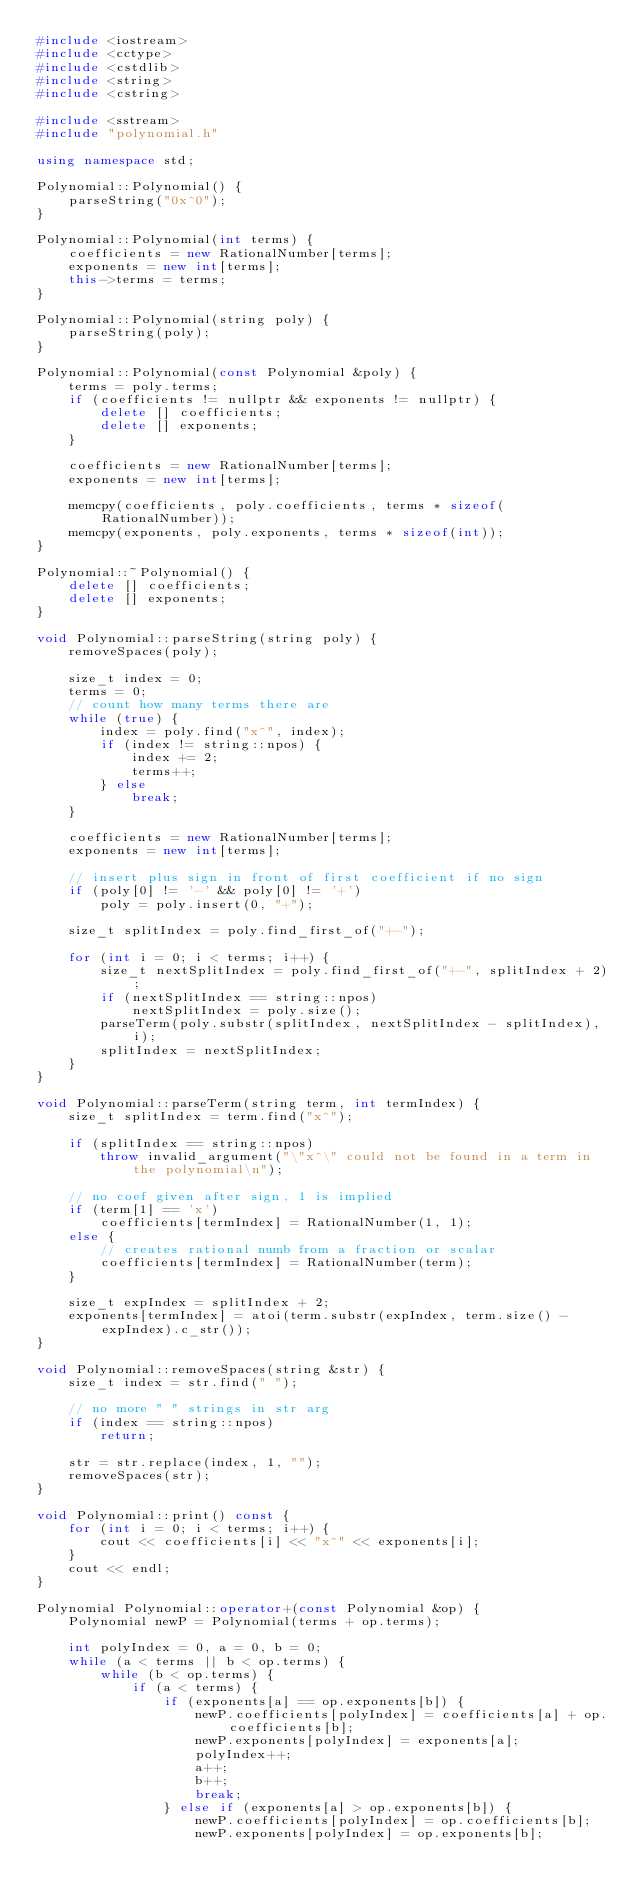Convert code to text. <code><loc_0><loc_0><loc_500><loc_500><_C++_>#include <iostream>
#include <cctype>
#include <cstdlib>
#include <string>
#include <cstring>

#include <sstream>
#include "polynomial.h"

using namespace std;

Polynomial::Polynomial() {
    parseString("0x^0");
}

Polynomial::Polynomial(int terms) {
    coefficients = new RationalNumber[terms];
    exponents = new int[terms];
    this->terms = terms;
}

Polynomial::Polynomial(string poly) {
    parseString(poly);
}

Polynomial::Polynomial(const Polynomial &poly) {
    terms = poly.terms;
    if (coefficients != nullptr && exponents != nullptr) {
        delete [] coefficients;
        delete [] exponents;
    }

    coefficients = new RationalNumber[terms];
    exponents = new int[terms];

    memcpy(coefficients, poly.coefficients, terms * sizeof(RationalNumber));
    memcpy(exponents, poly.exponents, terms * sizeof(int));
}

Polynomial::~Polynomial() {
    delete [] coefficients;
    delete [] exponents;
}

void Polynomial::parseString(string poly) {
    removeSpaces(poly);

    size_t index = 0;
    terms = 0;
    // count how many terms there are
    while (true) {
        index = poly.find("x^", index);
        if (index != string::npos) {
            index += 2;
            terms++;
        } else
            break;
    }

    coefficients = new RationalNumber[terms];
    exponents = new int[terms];

    // insert plus sign in front of first coefficient if no sign
    if (poly[0] != '-' && poly[0] != '+')
        poly = poly.insert(0, "+");

    size_t splitIndex = poly.find_first_of("+-");

    for (int i = 0; i < terms; i++) {
        size_t nextSplitIndex = poly.find_first_of("+-", splitIndex + 2);
        if (nextSplitIndex == string::npos)
            nextSplitIndex = poly.size();
        parseTerm(poly.substr(splitIndex, nextSplitIndex - splitIndex), i);
        splitIndex = nextSplitIndex;
    }
}

void Polynomial::parseTerm(string term, int termIndex) {
    size_t splitIndex = term.find("x^");

    if (splitIndex == string::npos)
        throw invalid_argument("\"x^\" could not be found in a term in the polynomial\n");

    // no coef given after sign, 1 is implied
    if (term[1] == 'x')
        coefficients[termIndex] = RationalNumber(1, 1);
    else {
        // creates rational numb from a fraction or scalar
        coefficients[termIndex] = RationalNumber(term);
    }

    size_t expIndex = splitIndex + 2;
    exponents[termIndex] = atoi(term.substr(expIndex, term.size() - expIndex).c_str());
}

void Polynomial::removeSpaces(string &str) {
    size_t index = str.find(" ");

    // no more " " strings in str arg
    if (index == string::npos)
        return;

    str = str.replace(index, 1, "");
    removeSpaces(str);
}

void Polynomial::print() const {
    for (int i = 0; i < terms; i++) {
        cout << coefficients[i] << "x^" << exponents[i];
    }
    cout << endl;
}

Polynomial Polynomial::operator+(const Polynomial &op) {
    Polynomial newP = Polynomial(terms + op.terms);

    int polyIndex = 0, a = 0, b = 0;
    while (a < terms || b < op.terms) {
        while (b < op.terms) {
            if (a < terms) {
                if (exponents[a] == op.exponents[b]) {
                    newP.coefficients[polyIndex] = coefficients[a] + op.coefficients[b];
                    newP.exponents[polyIndex] = exponents[a];
                    polyIndex++;
                    a++;
                    b++;
                    break;
                } else if (exponents[a] > op.exponents[b]) {
                    newP.coefficients[polyIndex] = op.coefficients[b];
                    newP.exponents[polyIndex] = op.exponents[b];</code> 